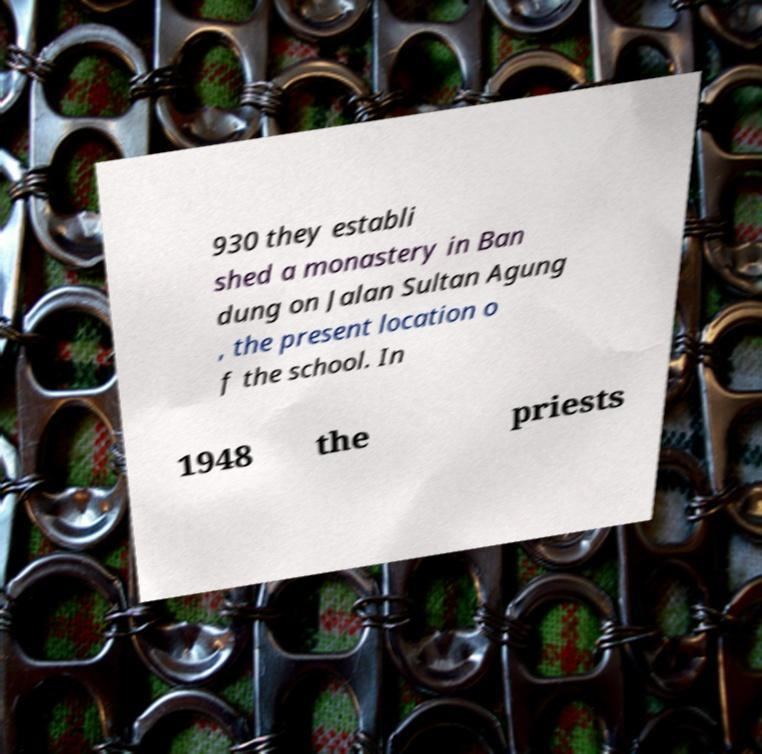For documentation purposes, I need the text within this image transcribed. Could you provide that? 930 they establi shed a monastery in Ban dung on Jalan Sultan Agung , the present location o f the school. In 1948 the priests 